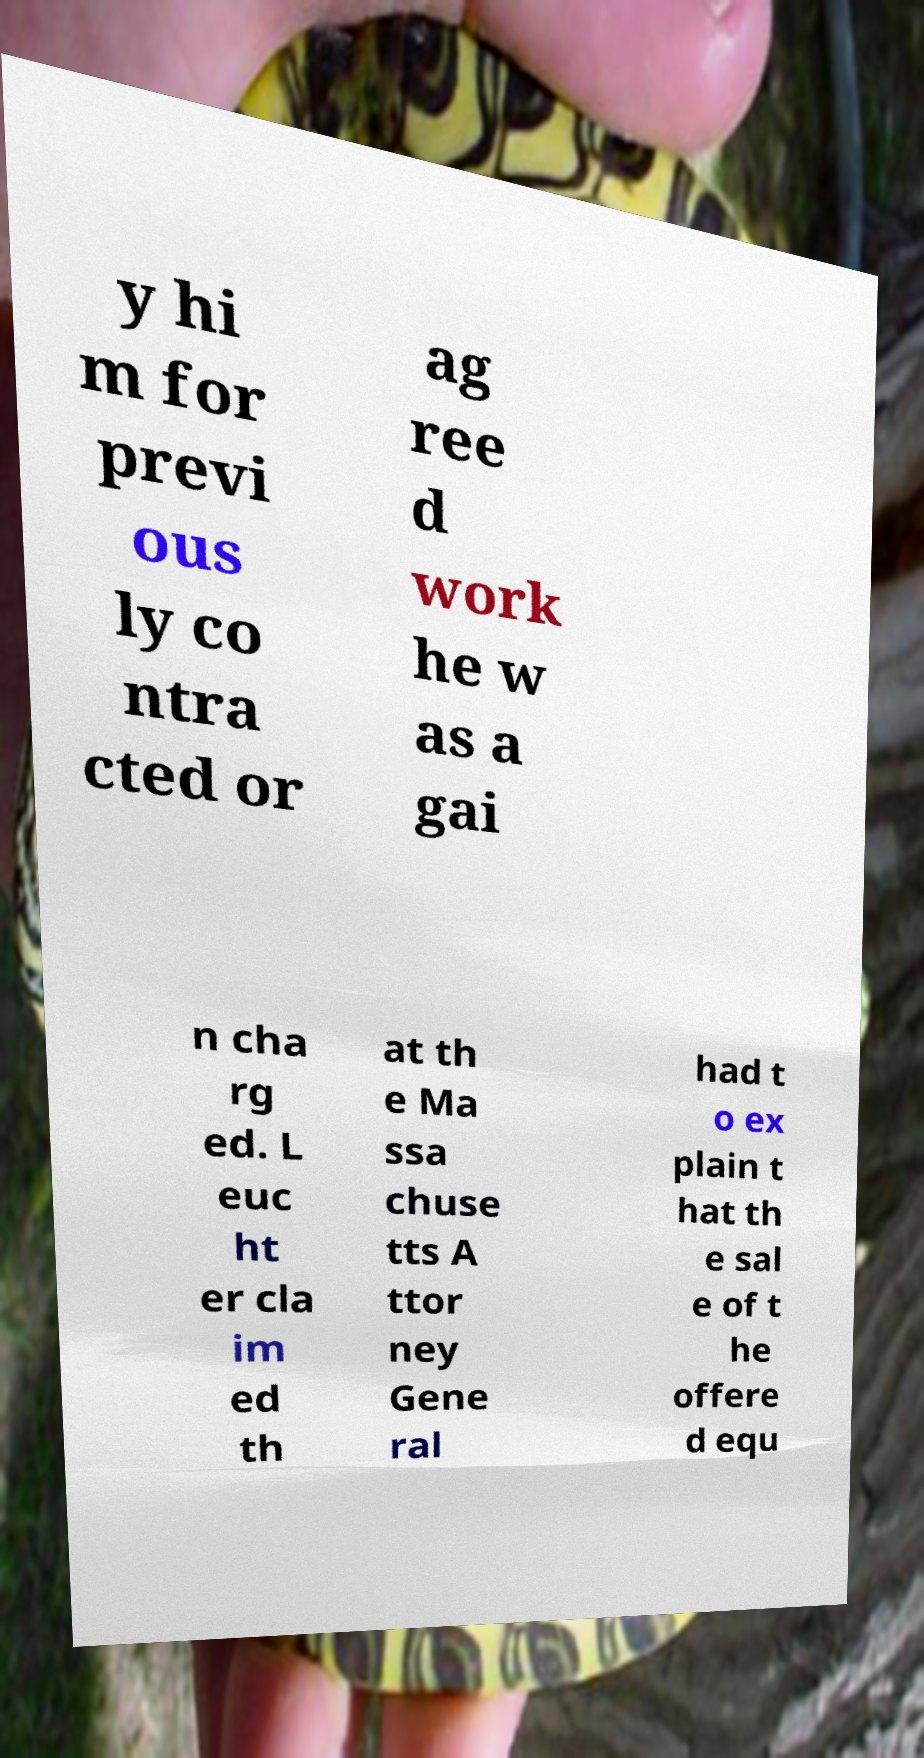Please identify and transcribe the text found in this image. y hi m for previ ous ly co ntra cted or ag ree d work he w as a gai n cha rg ed. L euc ht er cla im ed th at th e Ma ssa chuse tts A ttor ney Gene ral had t o ex plain t hat th e sal e of t he offere d equ 